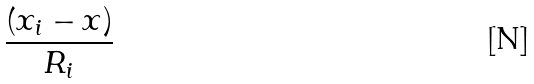Convert formula to latex. <formula><loc_0><loc_0><loc_500><loc_500>\frac { ( x _ { i } - x ) } { R _ { i } }</formula> 